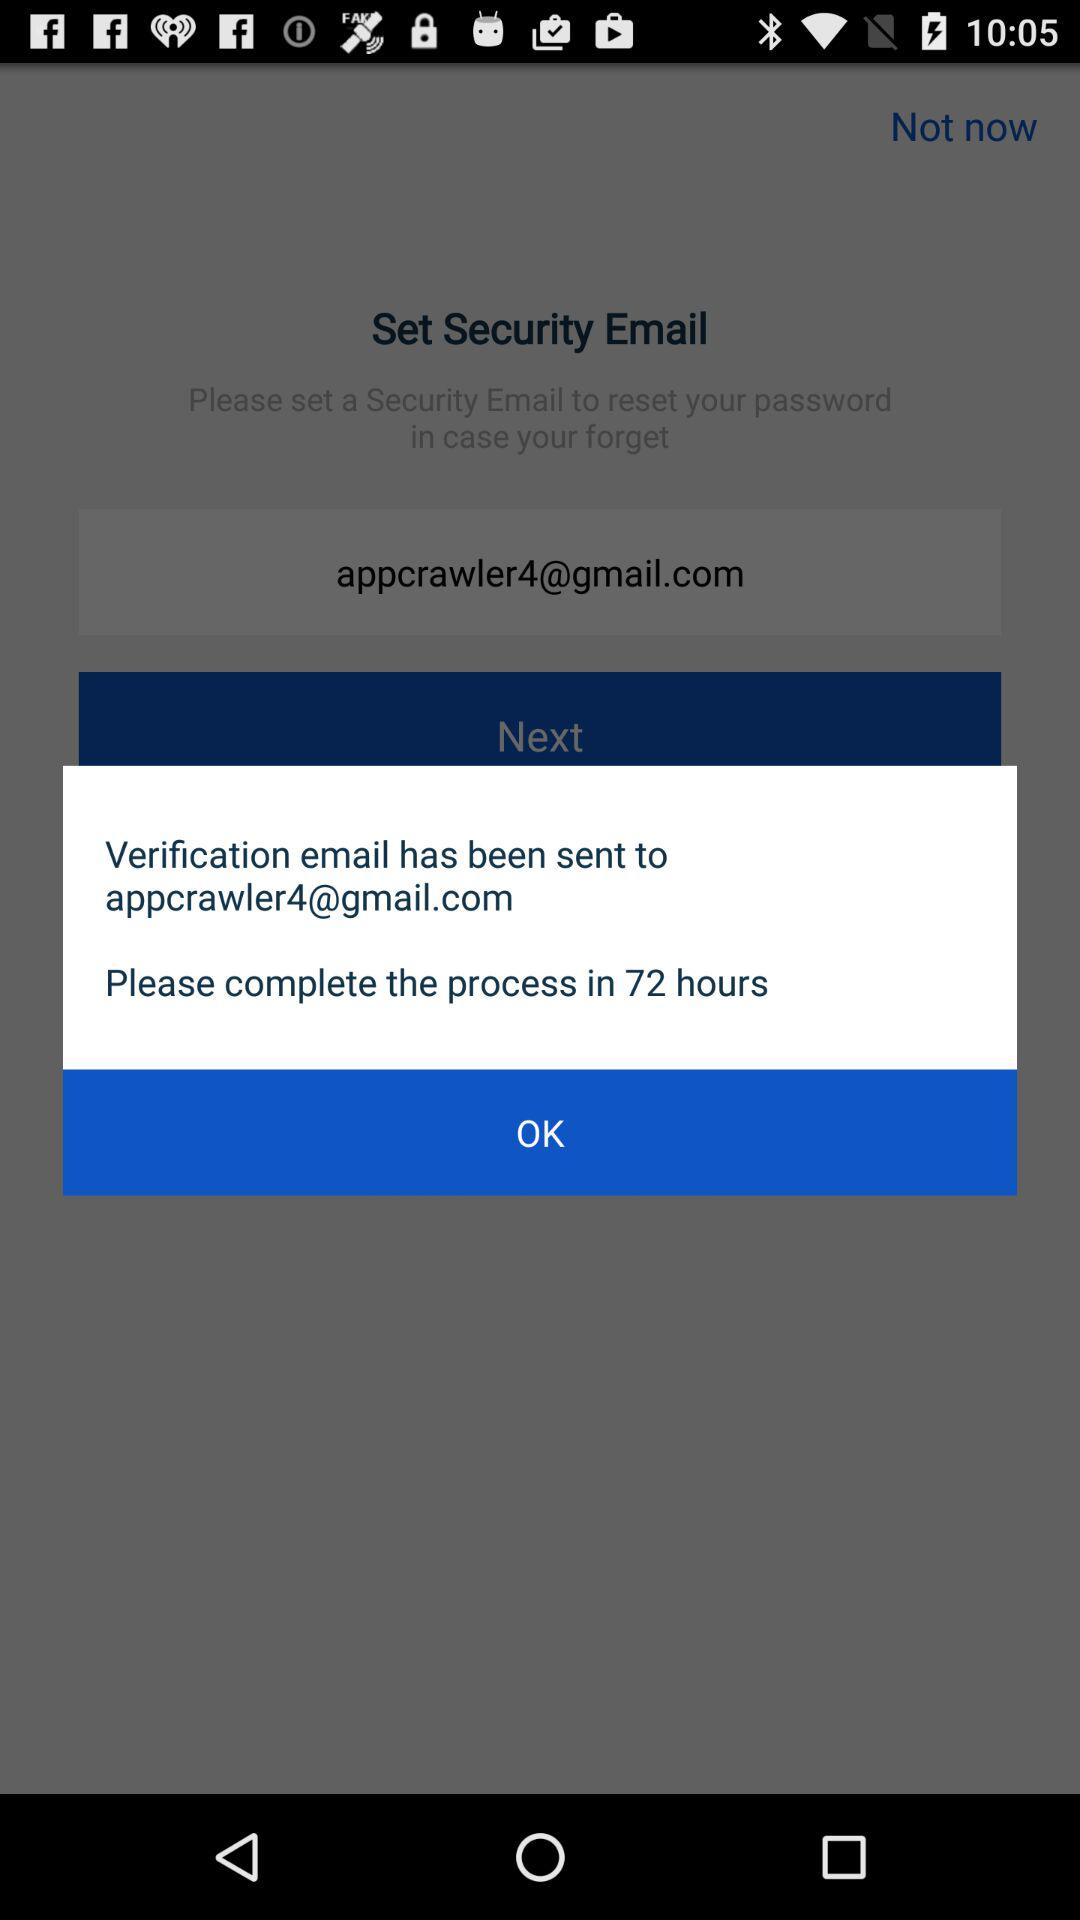In how much time do we have to complete the process? You have to complete the process in 72 hours. 